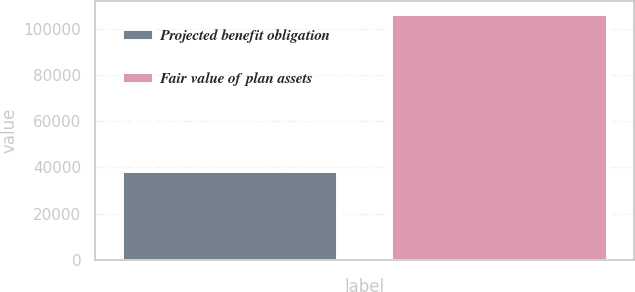<chart> <loc_0><loc_0><loc_500><loc_500><bar_chart><fcel>Projected benefit obligation<fcel>Fair value of plan assets<nl><fcel>38475<fcel>106572<nl></chart> 